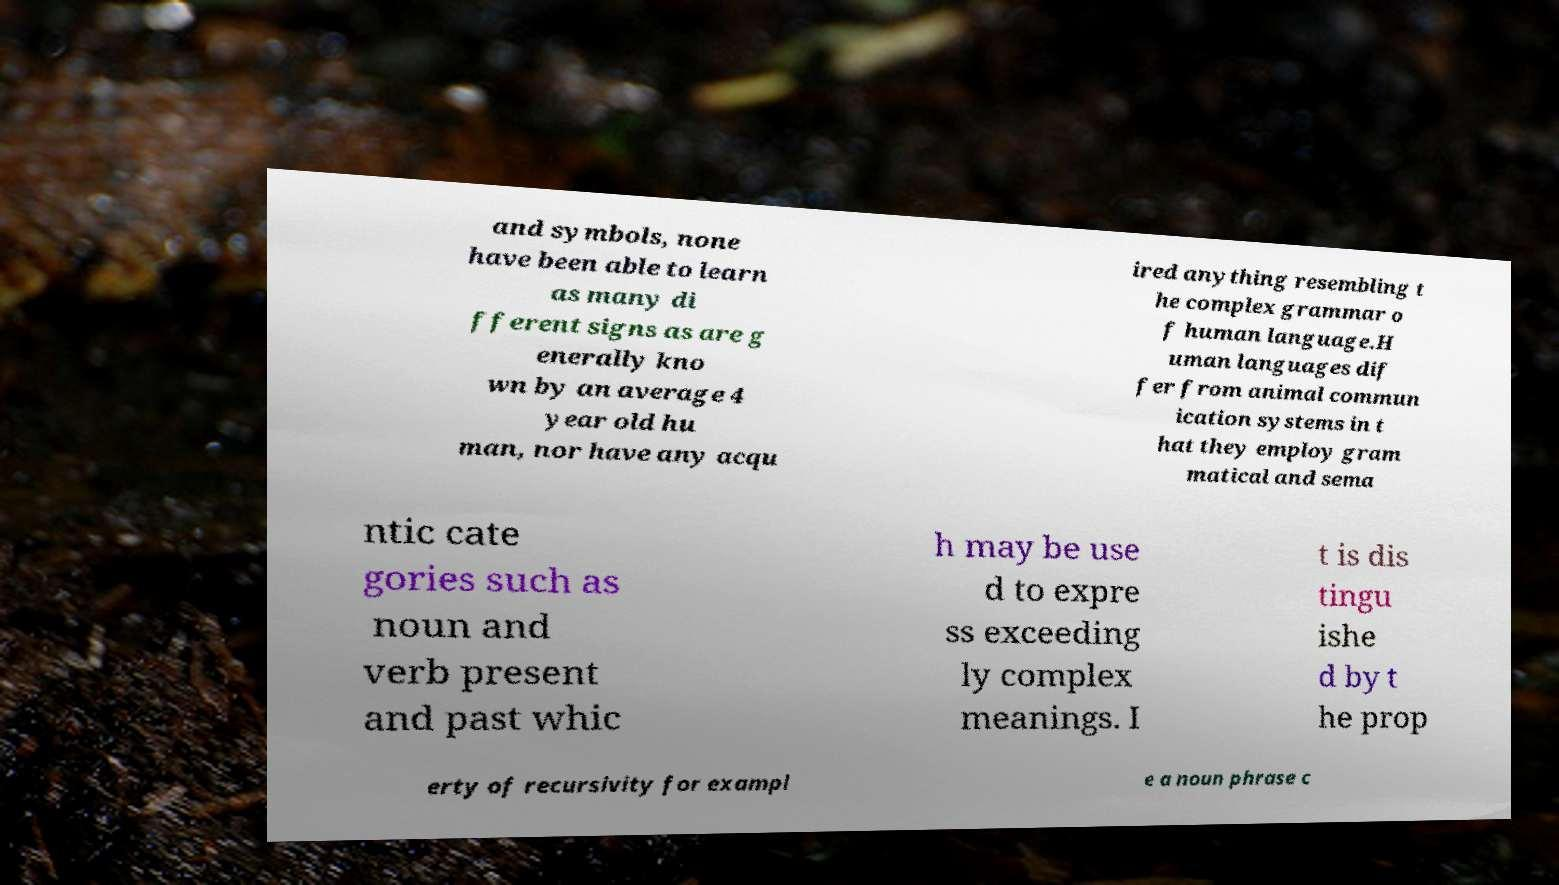Please identify and transcribe the text found in this image. and symbols, none have been able to learn as many di fferent signs as are g enerally kno wn by an average 4 year old hu man, nor have any acqu ired anything resembling t he complex grammar o f human language.H uman languages dif fer from animal commun ication systems in t hat they employ gram matical and sema ntic cate gories such as noun and verb present and past whic h may be use d to expre ss exceeding ly complex meanings. I t is dis tingu ishe d by t he prop erty of recursivity for exampl e a noun phrase c 